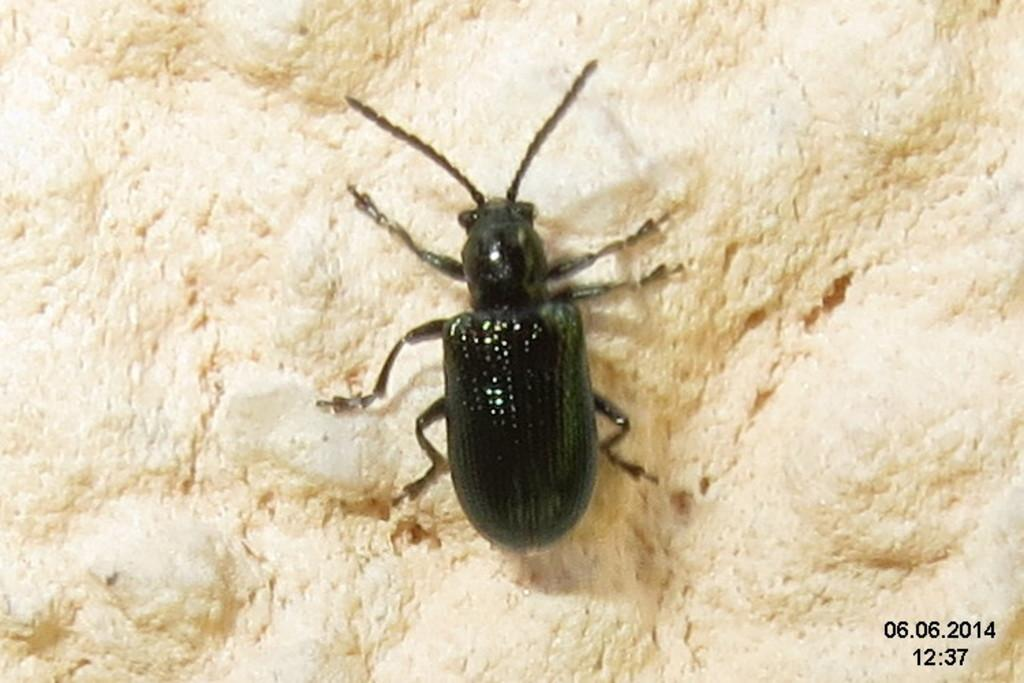What type of creature can be seen in the image? There is an insect present in the image. Where is the insect located? The insect is on a bed sheet. What type of cast can be seen on the sofa in the image? There is no cast or sofa present in the image; it only features an insect on a bed sheet. How many clovers are visible on the bed sheet in the image? There are no clovers visible in the image; it only features an insect on a bed sheet. 